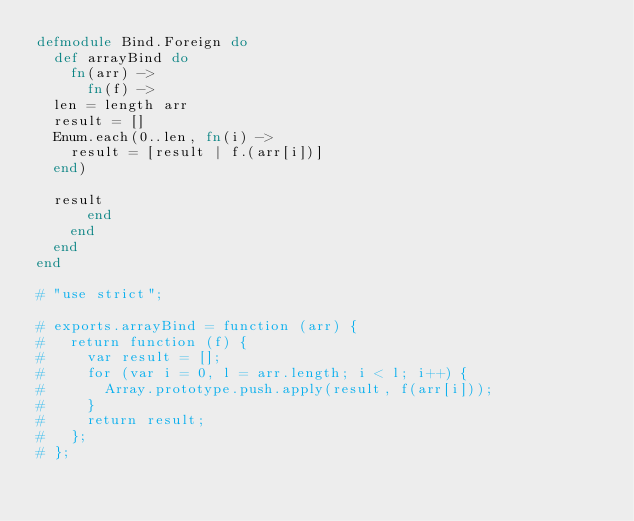Convert code to text. <code><loc_0><loc_0><loc_500><loc_500><_Elixir_>defmodule Bind.Foreign do
  def arrayBind do
    fn(arr) ->
      fn(f) ->
	len = length arr
	result = []
	Enum.each(0..len, fn(i) ->
	  result = [result | f.(arr[i])]
	end)

	result
      end
    end
  end
end

# "use strict";

# exports.arrayBind = function (arr) {
#   return function (f) {
#     var result = [];
#     for (var i = 0, l = arr.length; i < l; i++) {
#       Array.prototype.push.apply(result, f(arr[i]));
#     }
#     return result;
#   };
# };
</code> 